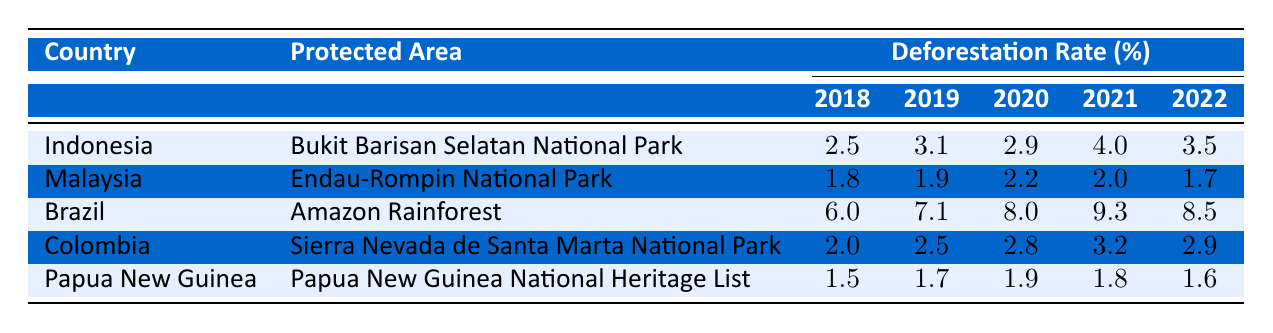What was the deforestation rate in Indonesia in 2020? By looking at the row for Indonesia, the deforestation rate in the year 2020 is listed as 2.9.
Answer: 2.9 What was the highest deforestation rate recorded among the countries in 2021? The rates for each country in 2021 are 4.0 (Indonesia), 2.0 (Malaysia), 9.3 (Brazil), 3.2 (Colombia), and 1.8 (Papua New Guinea). The highest rate is 9.3 from Brazil.
Answer: 9.3 Did Malaysia experience an increase in deforestation rates from 2018 to 2019? The deforestation rates for Malaysia show 1.8 for 2018 and 1.9 for 2019. Since 1.9 is greater than 1.8, this indicates an increase.
Answer: Yes What is the average deforestation rate for Brazil over the five years recorded? The deforestation rates for Brazil are 6.0, 7.1, 8.0, 9.3, and 8.5. To find the average, we sum these values: 6.0 + 7.1 + 8.0 + 9.3 + 8.5 = 38.9. Dividing by 5 gives us 38.9 / 5 = 7.78.
Answer: 7.78 Which country had the lowest recorded deforestation rate in 2019, and what was the rate? The rates for 2019 are 3.1 (Indonesia), 1.9 (Malaysia), 7.1 (Brazil), 2.5 (Colombia), and 1.7 (Papua New Guinea). The lowest rate is 1.7 from Papua New Guinea.
Answer: Papua New Guinea, 1.7 Was there a decrease in the deforestation rate in Malaysia from 2021 to 2022? The deforestation rates for Malaysia are 2.0 in 2021 and 1.7 in 2022. Since 1.7 is less than 2.0, this indicates a decrease.
Answer: Yes Which year had the highest overall deforestation rates across all countries? Analyzing the highest values for each year: 4.0 (2018), 3.1 (2019), 8.0 (2020), 9.3 (2021), and 8.5 (2022). The highest value is 9.3 from 2021.
Answer: 2021 What is the difference in deforestation rates from 2018 to 2022 for Colombia? The deforestation rates for Colombia are 2.0 (2018) and 2.9 (2022). The difference is 2.9 - 2.0 = 0.9, indicating an increase of 0.9.
Answer: 0.9 